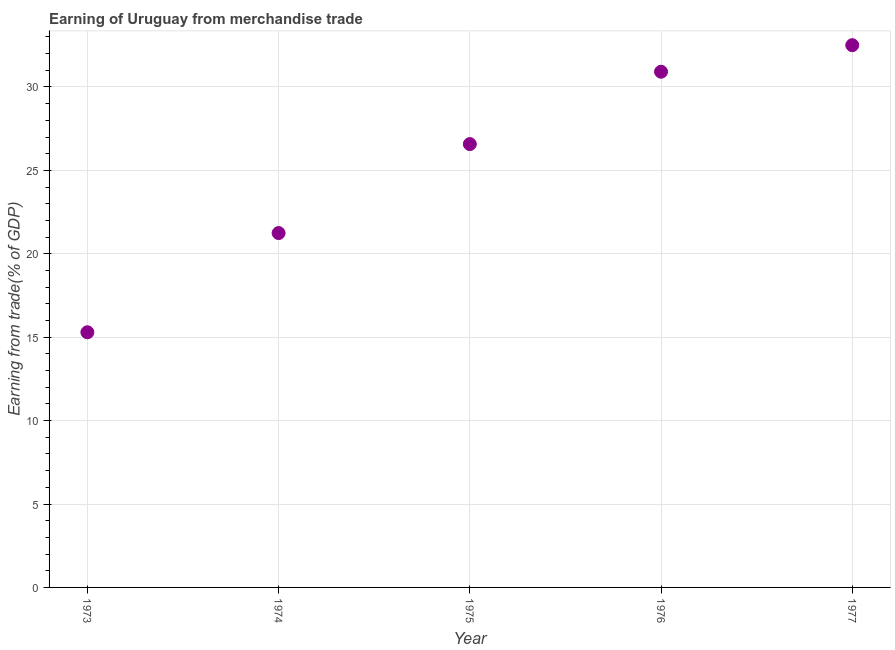What is the earning from merchandise trade in 1974?
Keep it short and to the point. 21.24. Across all years, what is the maximum earning from merchandise trade?
Provide a succinct answer. 32.5. Across all years, what is the minimum earning from merchandise trade?
Provide a short and direct response. 15.29. In which year was the earning from merchandise trade minimum?
Your answer should be compact. 1973. What is the sum of the earning from merchandise trade?
Provide a short and direct response. 126.53. What is the difference between the earning from merchandise trade in 1976 and 1977?
Offer a very short reply. -1.59. What is the average earning from merchandise trade per year?
Offer a terse response. 25.31. What is the median earning from merchandise trade?
Ensure brevity in your answer.  26.58. In how many years, is the earning from merchandise trade greater than 20 %?
Make the answer very short. 4. What is the ratio of the earning from merchandise trade in 1975 to that in 1976?
Ensure brevity in your answer.  0.86. Is the earning from merchandise trade in 1974 less than that in 1977?
Offer a terse response. Yes. Is the difference between the earning from merchandise trade in 1974 and 1977 greater than the difference between any two years?
Your answer should be very brief. No. What is the difference between the highest and the second highest earning from merchandise trade?
Give a very brief answer. 1.59. What is the difference between the highest and the lowest earning from merchandise trade?
Your answer should be very brief. 17.21. How many dotlines are there?
Your answer should be very brief. 1. How many years are there in the graph?
Offer a terse response. 5. Are the values on the major ticks of Y-axis written in scientific E-notation?
Your answer should be compact. No. What is the title of the graph?
Provide a short and direct response. Earning of Uruguay from merchandise trade. What is the label or title of the Y-axis?
Provide a short and direct response. Earning from trade(% of GDP). What is the Earning from trade(% of GDP) in 1973?
Your answer should be compact. 15.29. What is the Earning from trade(% of GDP) in 1974?
Your response must be concise. 21.24. What is the Earning from trade(% of GDP) in 1975?
Provide a succinct answer. 26.58. What is the Earning from trade(% of GDP) in 1976?
Your answer should be very brief. 30.91. What is the Earning from trade(% of GDP) in 1977?
Make the answer very short. 32.5. What is the difference between the Earning from trade(% of GDP) in 1973 and 1974?
Give a very brief answer. -5.95. What is the difference between the Earning from trade(% of GDP) in 1973 and 1975?
Provide a short and direct response. -11.28. What is the difference between the Earning from trade(% of GDP) in 1973 and 1976?
Your response must be concise. -15.62. What is the difference between the Earning from trade(% of GDP) in 1973 and 1977?
Offer a very short reply. -17.21. What is the difference between the Earning from trade(% of GDP) in 1974 and 1975?
Your answer should be compact. -5.33. What is the difference between the Earning from trade(% of GDP) in 1974 and 1976?
Your response must be concise. -9.67. What is the difference between the Earning from trade(% of GDP) in 1974 and 1977?
Ensure brevity in your answer.  -11.26. What is the difference between the Earning from trade(% of GDP) in 1975 and 1976?
Your answer should be very brief. -4.34. What is the difference between the Earning from trade(% of GDP) in 1975 and 1977?
Offer a terse response. -5.93. What is the difference between the Earning from trade(% of GDP) in 1976 and 1977?
Offer a terse response. -1.59. What is the ratio of the Earning from trade(% of GDP) in 1973 to that in 1974?
Give a very brief answer. 0.72. What is the ratio of the Earning from trade(% of GDP) in 1973 to that in 1975?
Offer a very short reply. 0.58. What is the ratio of the Earning from trade(% of GDP) in 1973 to that in 1976?
Your answer should be very brief. 0.49. What is the ratio of the Earning from trade(% of GDP) in 1973 to that in 1977?
Keep it short and to the point. 0.47. What is the ratio of the Earning from trade(% of GDP) in 1974 to that in 1975?
Ensure brevity in your answer.  0.8. What is the ratio of the Earning from trade(% of GDP) in 1974 to that in 1976?
Provide a succinct answer. 0.69. What is the ratio of the Earning from trade(% of GDP) in 1974 to that in 1977?
Make the answer very short. 0.65. What is the ratio of the Earning from trade(% of GDP) in 1975 to that in 1976?
Ensure brevity in your answer.  0.86. What is the ratio of the Earning from trade(% of GDP) in 1975 to that in 1977?
Your response must be concise. 0.82. What is the ratio of the Earning from trade(% of GDP) in 1976 to that in 1977?
Your answer should be compact. 0.95. 